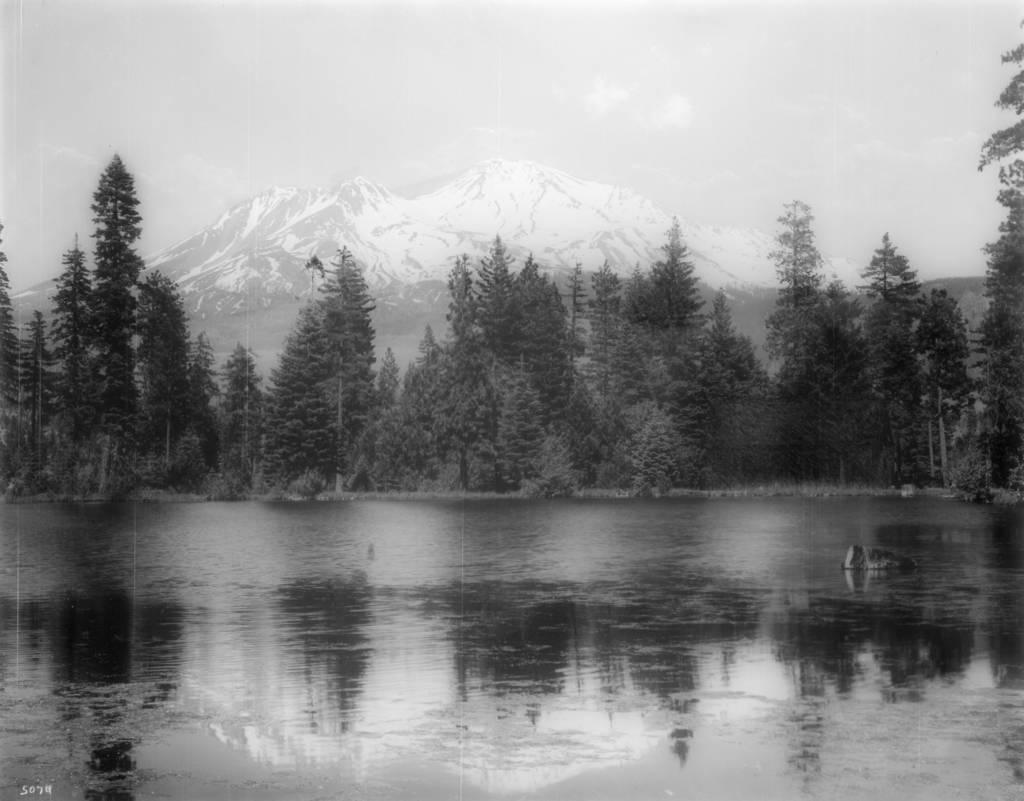What is visible in the image? Water, trees, mountains, and the sky are visible in the image. What type of natural environment is depicted in the image? The image shows a landscape with water, trees, and mountains. How are the trees positioned in relation to the water? The trees are surrounding the water in the image. What color is the sheet draped over the mountain in the image? There is no sheet present in the image; it features water, trees, mountains, and the sky. 